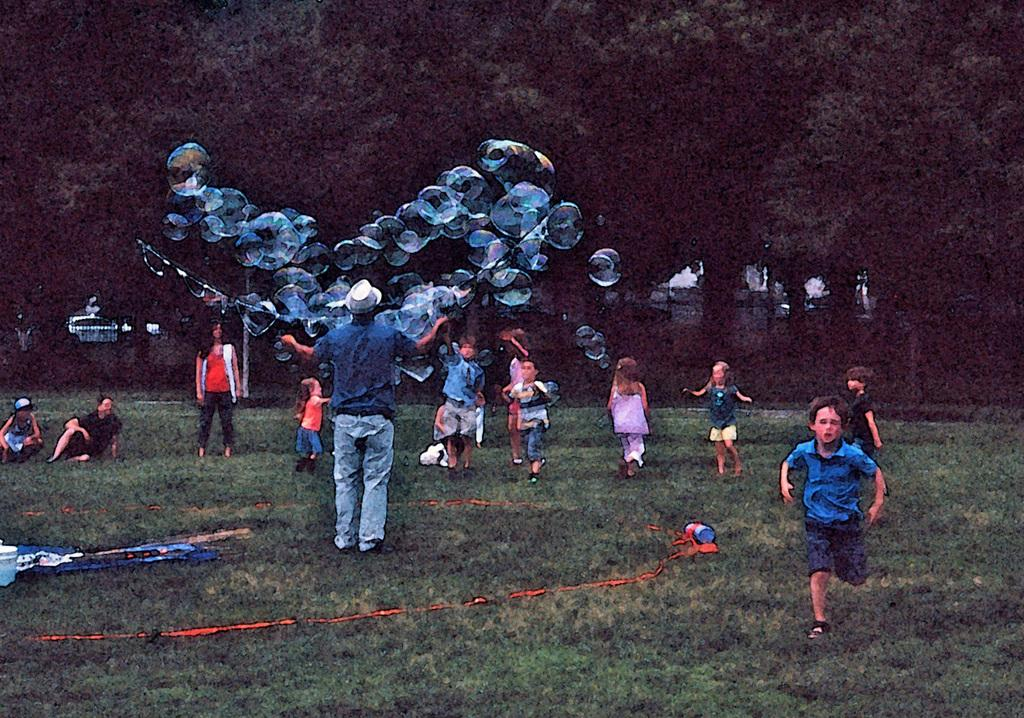Who is present in the image? There is a man in the image. What is the man holding in the image? The man is holding water balloons. What are the kids doing in the image? The kids are playing in the image. What can be seen in the background of the image? There are trees in the background of the image. What type of ground is visible at the bottom of the image? There is grass at the bottom of the image. What type of glove is the man wearing while holding the water balloons? The man is not wearing any gloves in the image; he is simply holding the water balloons. 